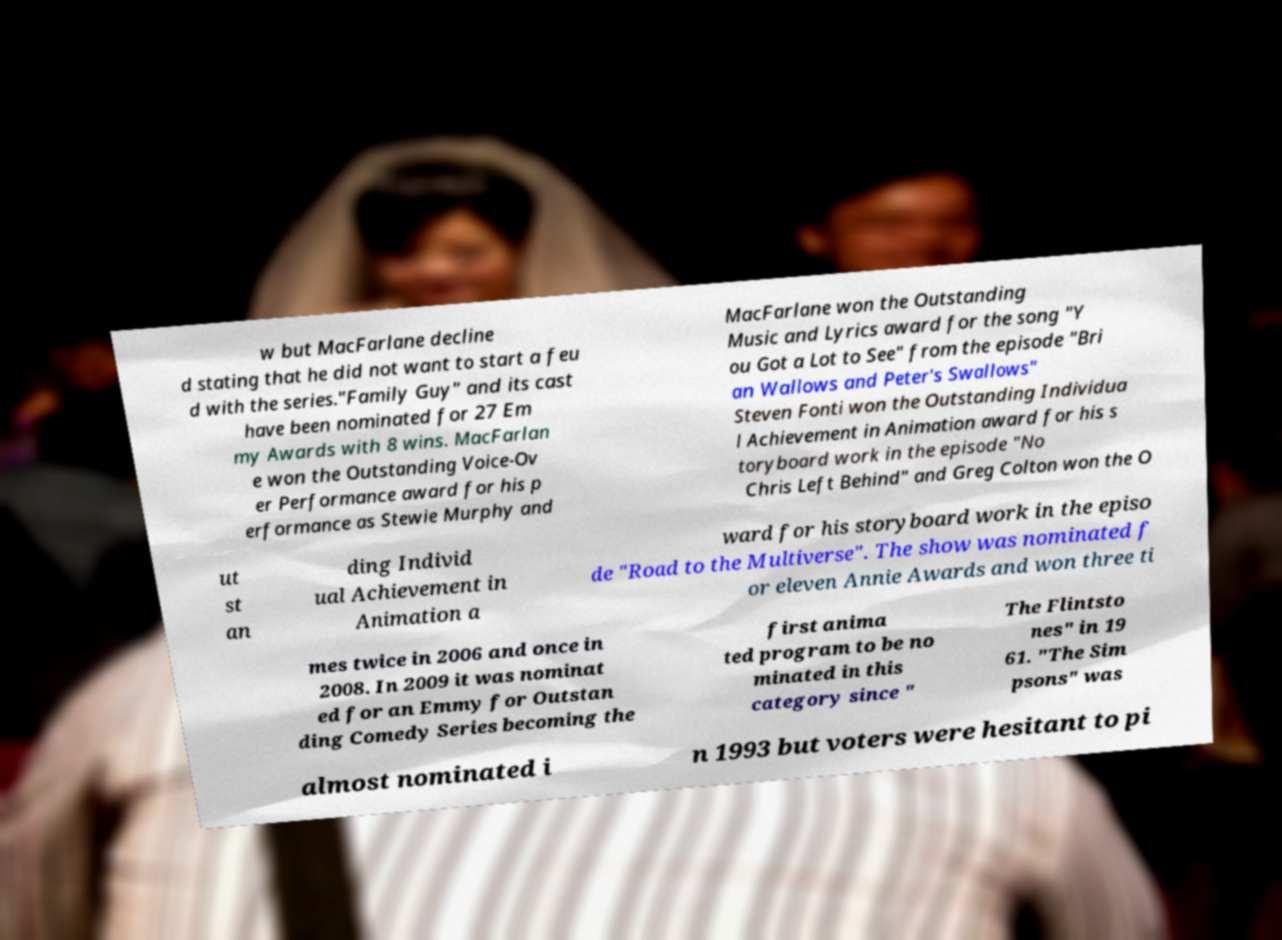I need the written content from this picture converted into text. Can you do that? w but MacFarlane decline d stating that he did not want to start a feu d with the series."Family Guy" and its cast have been nominated for 27 Em my Awards with 8 wins. MacFarlan e won the Outstanding Voice-Ov er Performance award for his p erformance as Stewie Murphy and MacFarlane won the Outstanding Music and Lyrics award for the song "Y ou Got a Lot to See" from the episode "Bri an Wallows and Peter's Swallows" Steven Fonti won the Outstanding Individua l Achievement in Animation award for his s toryboard work in the episode "No Chris Left Behind" and Greg Colton won the O ut st an ding Individ ual Achievement in Animation a ward for his storyboard work in the episo de "Road to the Multiverse". The show was nominated f or eleven Annie Awards and won three ti mes twice in 2006 and once in 2008. In 2009 it was nominat ed for an Emmy for Outstan ding Comedy Series becoming the first anima ted program to be no minated in this category since " The Flintsto nes" in 19 61. "The Sim psons" was almost nominated i n 1993 but voters were hesitant to pi 